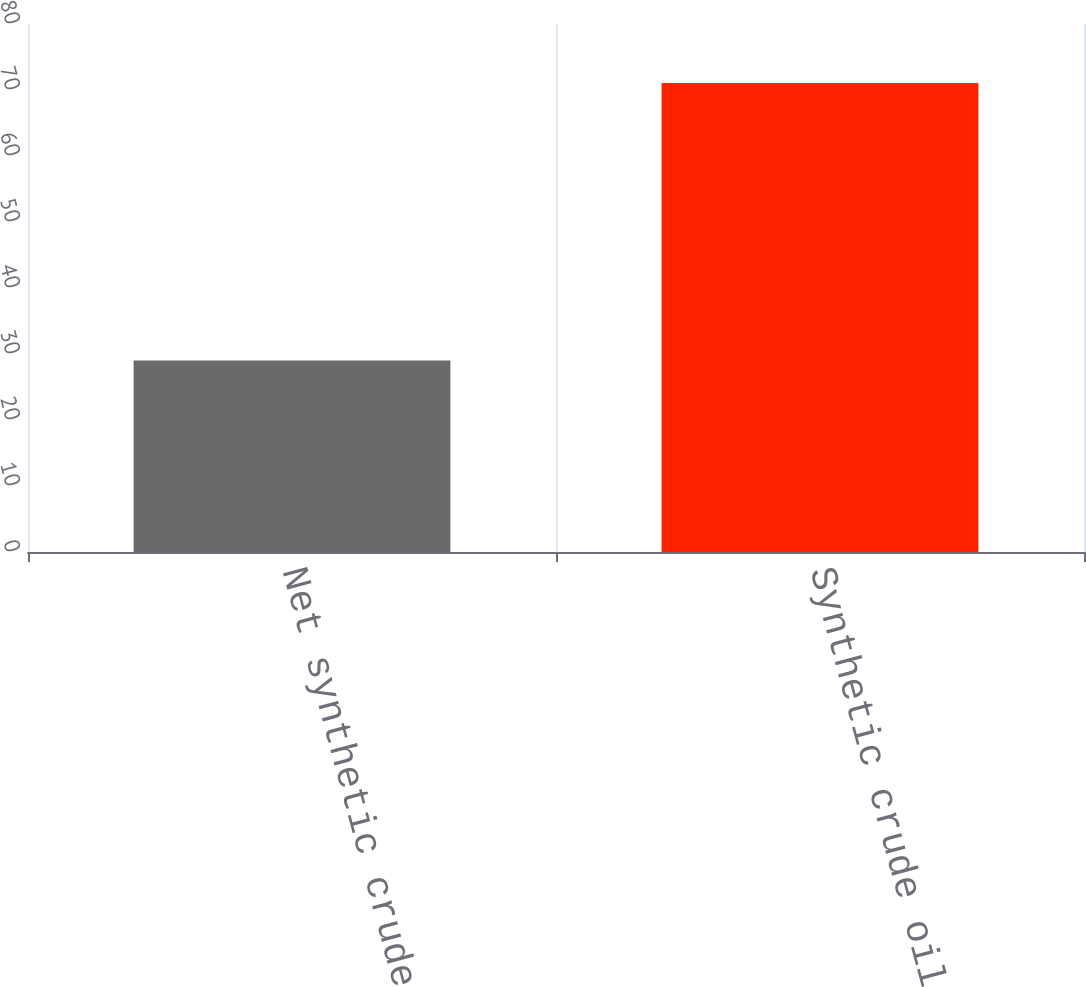<chart> <loc_0><loc_0><loc_500><loc_500><bar_chart><fcel>Net synthetic crude oil sales<fcel>Synthetic crude oil average<nl><fcel>29<fcel>71.06<nl></chart> 